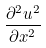<formula> <loc_0><loc_0><loc_500><loc_500>\frac { \partial ^ { 2 } u ^ { 2 } } { \partial x ^ { 2 } }</formula> 